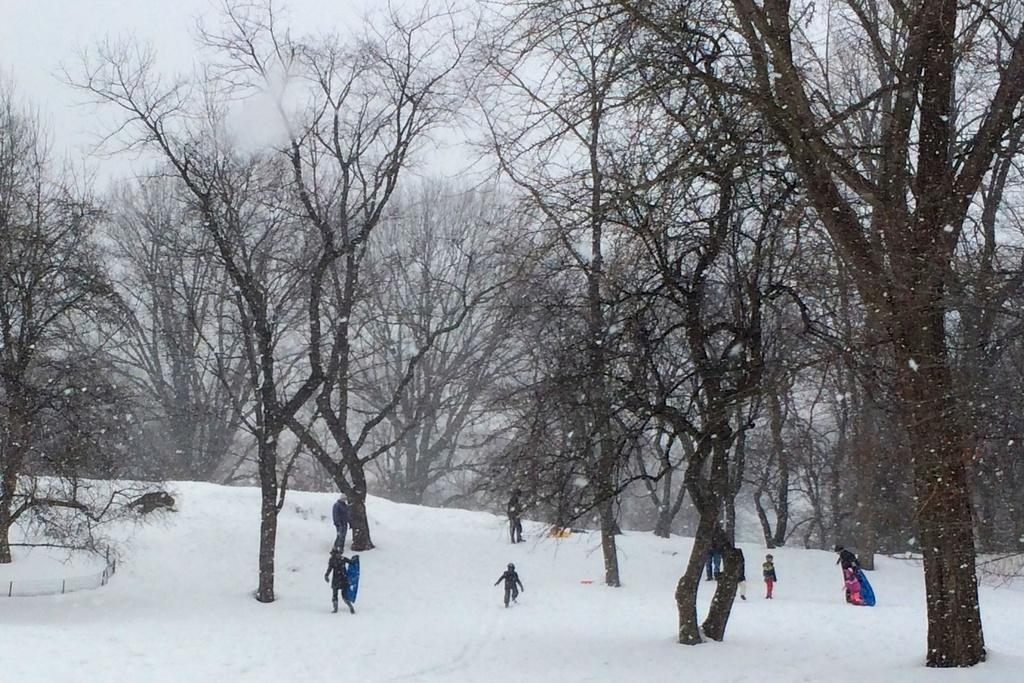What type of vegetation is present in the image? There are dry trees in the image. Can you describe the people in the image? There are people in the image. What is the weather like in the image? There is snow visible in the image, indicating a cold and snowy environment. What is the person holding in the image? A person is holding something, but the specific object cannot be determined from the provided facts. What is the color of the sky in the image? The sky appears to be white in color. What decision is being made by the person holding the needle in the image? There is no needle present in the image, and therefore no decision-making involving a needle can be observed. 